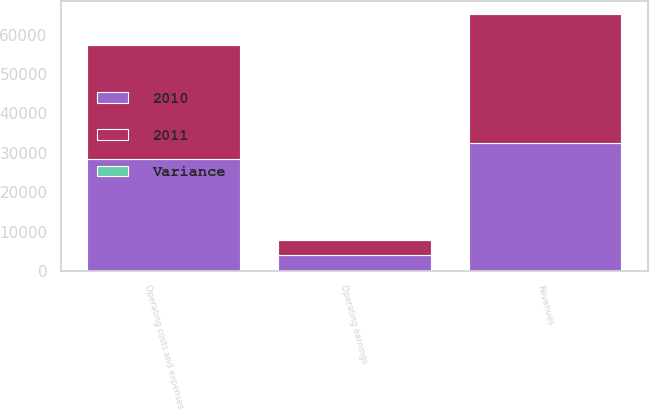<chart> <loc_0><loc_0><loc_500><loc_500><stacked_bar_chart><ecel><fcel>Revenues<fcel>Operating costs and expenses<fcel>Operating earnings<nl><fcel>2010<fcel>32466<fcel>28521<fcel>3945<nl><fcel>2011<fcel>32677<fcel>28851<fcel>3826<nl><fcel>Variance<fcel>211<fcel>330<fcel>119<nl></chart> 